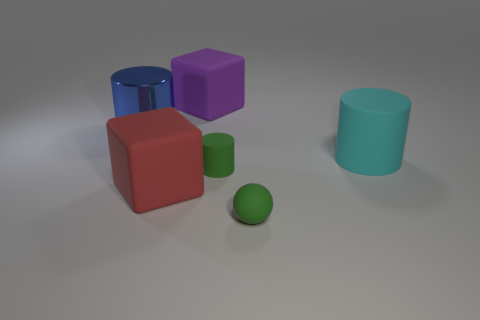There is a big rubber thing that is both to the left of the green cylinder and behind the large red thing; what shape is it?
Your response must be concise. Cube. What number of objects are either rubber blocks behind the big red rubber thing or large matte blocks to the left of the large purple matte thing?
Make the answer very short. 2. What number of other objects are the same size as the purple object?
Offer a terse response. 3. There is a cube that is behind the big cyan cylinder; is its color the same as the small rubber ball?
Keep it short and to the point. No. How big is the matte thing that is both in front of the cyan thing and left of the green matte cylinder?
Offer a very short reply. Large. What number of small things are either blue metallic cylinders or green things?
Ensure brevity in your answer.  2. There is a big blue metallic thing behind the big cyan matte thing; what is its shape?
Ensure brevity in your answer.  Cylinder. What number of big red matte blocks are there?
Ensure brevity in your answer.  1. Does the small cylinder have the same material as the large purple block?
Your answer should be very brief. Yes. Is the number of metal cylinders that are right of the blue thing greater than the number of big gray rubber blocks?
Provide a short and direct response. No. 